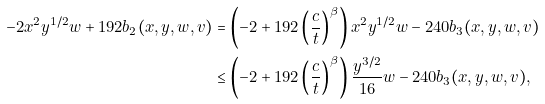<formula> <loc_0><loc_0><loc_500><loc_500>- 2 x ^ { 2 } y ^ { 1 / 2 } w + 1 9 2 b _ { 2 } ( x , y , w , v ) & = \left ( - 2 + 1 9 2 \left ( \frac { c } { t } \right ) ^ { \beta } \right ) x ^ { 2 } y ^ { 1 / 2 } w - 2 4 0 b _ { 3 } ( x , y , w , v ) \\ & \leq \left ( - 2 + 1 9 2 \left ( \frac { c } { t } \right ) ^ { \beta } \right ) \frac { y ^ { 3 / 2 } } { 1 6 } w - 2 4 0 b _ { 3 } ( x , y , w , v ) ,</formula> 